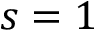<formula> <loc_0><loc_0><loc_500><loc_500>s = 1</formula> 